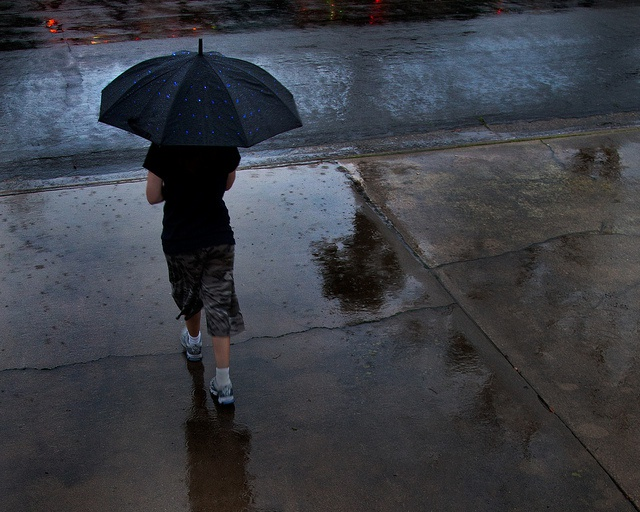Describe the objects in this image and their specific colors. I can see people in black, gray, and darkgray tones and umbrella in black, navy, darkblue, and gray tones in this image. 